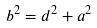Convert formula to latex. <formula><loc_0><loc_0><loc_500><loc_500>b ^ { 2 } = d ^ { 2 } + a ^ { 2 }</formula> 